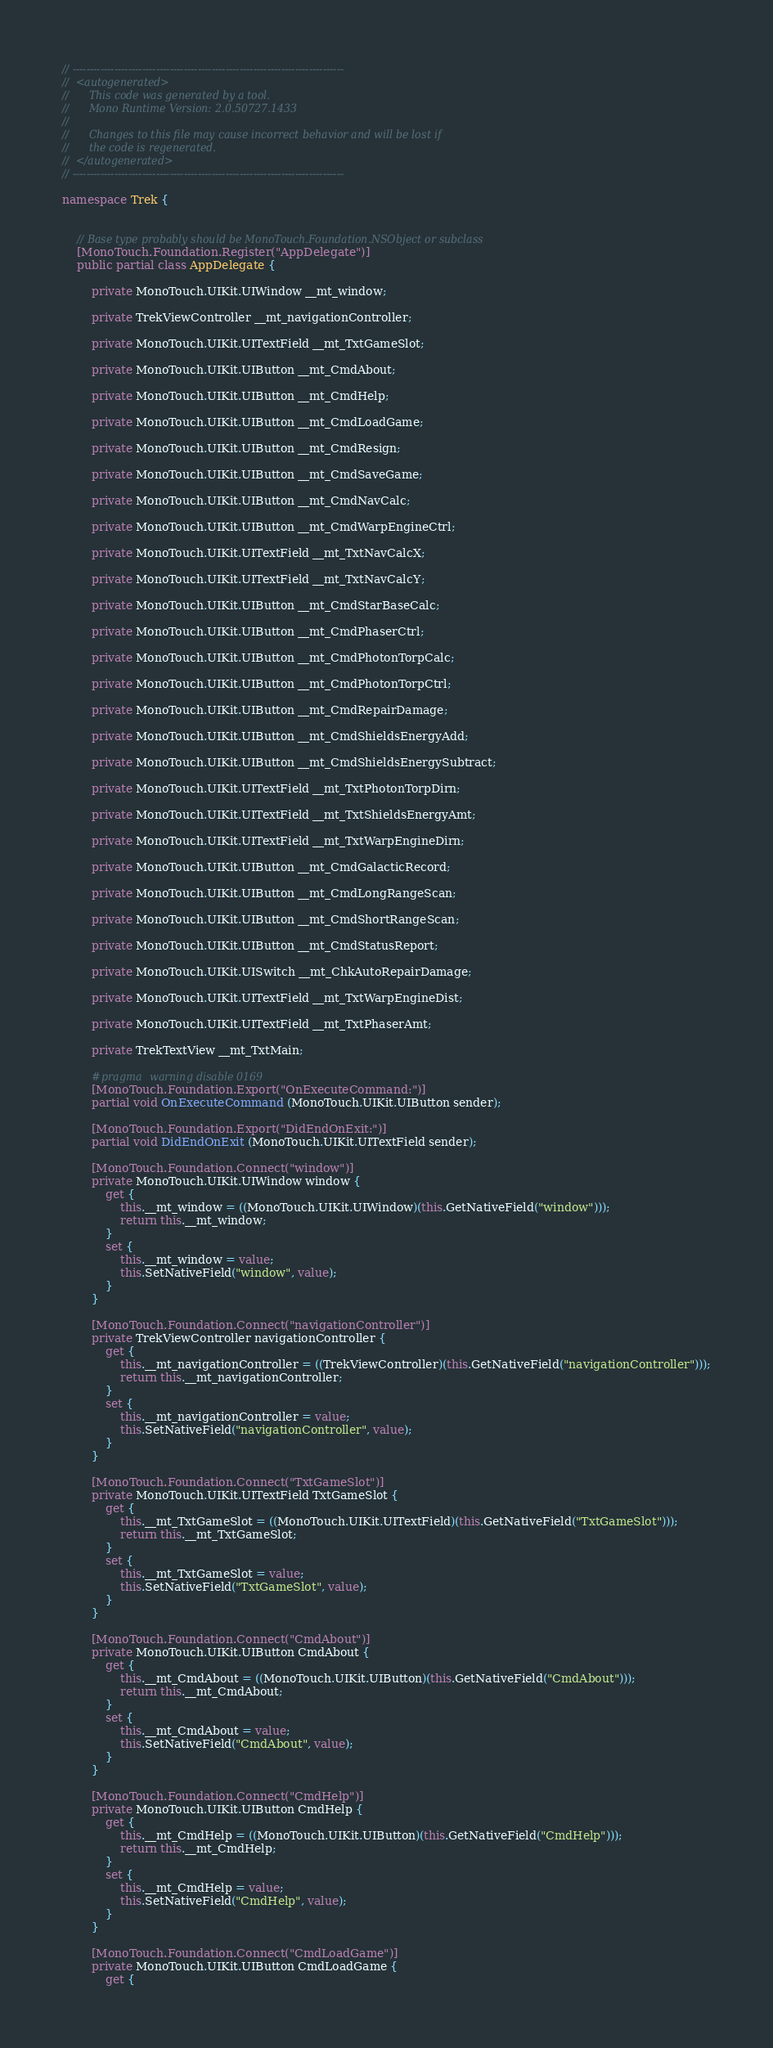Convert code to text. <code><loc_0><loc_0><loc_500><loc_500><_C#_>// ------------------------------------------------------------------------------
//  <autogenerated>
//      This code was generated by a tool.
//      Mono Runtime Version: 2.0.50727.1433
// 
//      Changes to this file may cause incorrect behavior and will be lost if 
//      the code is regenerated.
//  </autogenerated>
// ------------------------------------------------------------------------------

namespace Trek {
	
	
	// Base type probably should be MonoTouch.Foundation.NSObject or subclass
	[MonoTouch.Foundation.Register("AppDelegate")]
	public partial class AppDelegate {
		
		private MonoTouch.UIKit.UIWindow __mt_window;
		
		private TrekViewController __mt_navigationController;
		
		private MonoTouch.UIKit.UITextField __mt_TxtGameSlot;
		
		private MonoTouch.UIKit.UIButton __mt_CmdAbout;
		
		private MonoTouch.UIKit.UIButton __mt_CmdHelp;
		
		private MonoTouch.UIKit.UIButton __mt_CmdLoadGame;
		
		private MonoTouch.UIKit.UIButton __mt_CmdResign;
		
		private MonoTouch.UIKit.UIButton __mt_CmdSaveGame;
		
		private MonoTouch.UIKit.UIButton __mt_CmdNavCalc;
		
		private MonoTouch.UIKit.UIButton __mt_CmdWarpEngineCtrl;
		
		private MonoTouch.UIKit.UITextField __mt_TxtNavCalcX;
		
		private MonoTouch.UIKit.UITextField __mt_TxtNavCalcY;
		
		private MonoTouch.UIKit.UIButton __mt_CmdStarBaseCalc;
		
		private MonoTouch.UIKit.UIButton __mt_CmdPhaserCtrl;
		
		private MonoTouch.UIKit.UIButton __mt_CmdPhotonTorpCalc;
		
		private MonoTouch.UIKit.UIButton __mt_CmdPhotonTorpCtrl;
		
		private MonoTouch.UIKit.UIButton __mt_CmdRepairDamage;
		
		private MonoTouch.UIKit.UIButton __mt_CmdShieldsEnergyAdd;
		
		private MonoTouch.UIKit.UIButton __mt_CmdShieldsEnergySubtract;
		
		private MonoTouch.UIKit.UITextField __mt_TxtPhotonTorpDirn;
		
		private MonoTouch.UIKit.UITextField __mt_TxtShieldsEnergyAmt;
		
		private MonoTouch.UIKit.UITextField __mt_TxtWarpEngineDirn;
		
		private MonoTouch.UIKit.UIButton __mt_CmdGalacticRecord;
		
		private MonoTouch.UIKit.UIButton __mt_CmdLongRangeScan;
		
		private MonoTouch.UIKit.UIButton __mt_CmdShortRangeScan;
		
		private MonoTouch.UIKit.UIButton __mt_CmdStatusReport;
		
		private MonoTouch.UIKit.UISwitch __mt_ChkAutoRepairDamage;
		
		private MonoTouch.UIKit.UITextField __mt_TxtWarpEngineDist;
		
		private MonoTouch.UIKit.UITextField __mt_TxtPhaserAmt;
		
		private TrekTextView __mt_TxtMain;
		
		#pragma warning disable 0169
		[MonoTouch.Foundation.Export("OnExecuteCommand:")]
		partial void OnExecuteCommand (MonoTouch.UIKit.UIButton sender);

		[MonoTouch.Foundation.Export("DidEndOnExit:")]
		partial void DidEndOnExit (MonoTouch.UIKit.UITextField sender);

		[MonoTouch.Foundation.Connect("window")]
		private MonoTouch.UIKit.UIWindow window {
			get {
				this.__mt_window = ((MonoTouch.UIKit.UIWindow)(this.GetNativeField("window")));
				return this.__mt_window;
			}
			set {
				this.__mt_window = value;
				this.SetNativeField("window", value);
			}
		}
		
		[MonoTouch.Foundation.Connect("navigationController")]
		private TrekViewController navigationController {
			get {
				this.__mt_navigationController = ((TrekViewController)(this.GetNativeField("navigationController")));
				return this.__mt_navigationController;
			}
			set {
				this.__mt_navigationController = value;
				this.SetNativeField("navigationController", value);
			}
		}
		
		[MonoTouch.Foundation.Connect("TxtGameSlot")]
		private MonoTouch.UIKit.UITextField TxtGameSlot {
			get {
				this.__mt_TxtGameSlot = ((MonoTouch.UIKit.UITextField)(this.GetNativeField("TxtGameSlot")));
				return this.__mt_TxtGameSlot;
			}
			set {
				this.__mt_TxtGameSlot = value;
				this.SetNativeField("TxtGameSlot", value);
			}
		}
		
		[MonoTouch.Foundation.Connect("CmdAbout")]
		private MonoTouch.UIKit.UIButton CmdAbout {
			get {
				this.__mt_CmdAbout = ((MonoTouch.UIKit.UIButton)(this.GetNativeField("CmdAbout")));
				return this.__mt_CmdAbout;
			}
			set {
				this.__mt_CmdAbout = value;
				this.SetNativeField("CmdAbout", value);
			}
		}
		
		[MonoTouch.Foundation.Connect("CmdHelp")]
		private MonoTouch.UIKit.UIButton CmdHelp {
			get {
				this.__mt_CmdHelp = ((MonoTouch.UIKit.UIButton)(this.GetNativeField("CmdHelp")));
				return this.__mt_CmdHelp;
			}
			set {
				this.__mt_CmdHelp = value;
				this.SetNativeField("CmdHelp", value);
			}
		}
		
		[MonoTouch.Foundation.Connect("CmdLoadGame")]
		private MonoTouch.UIKit.UIButton CmdLoadGame {
			get {</code> 